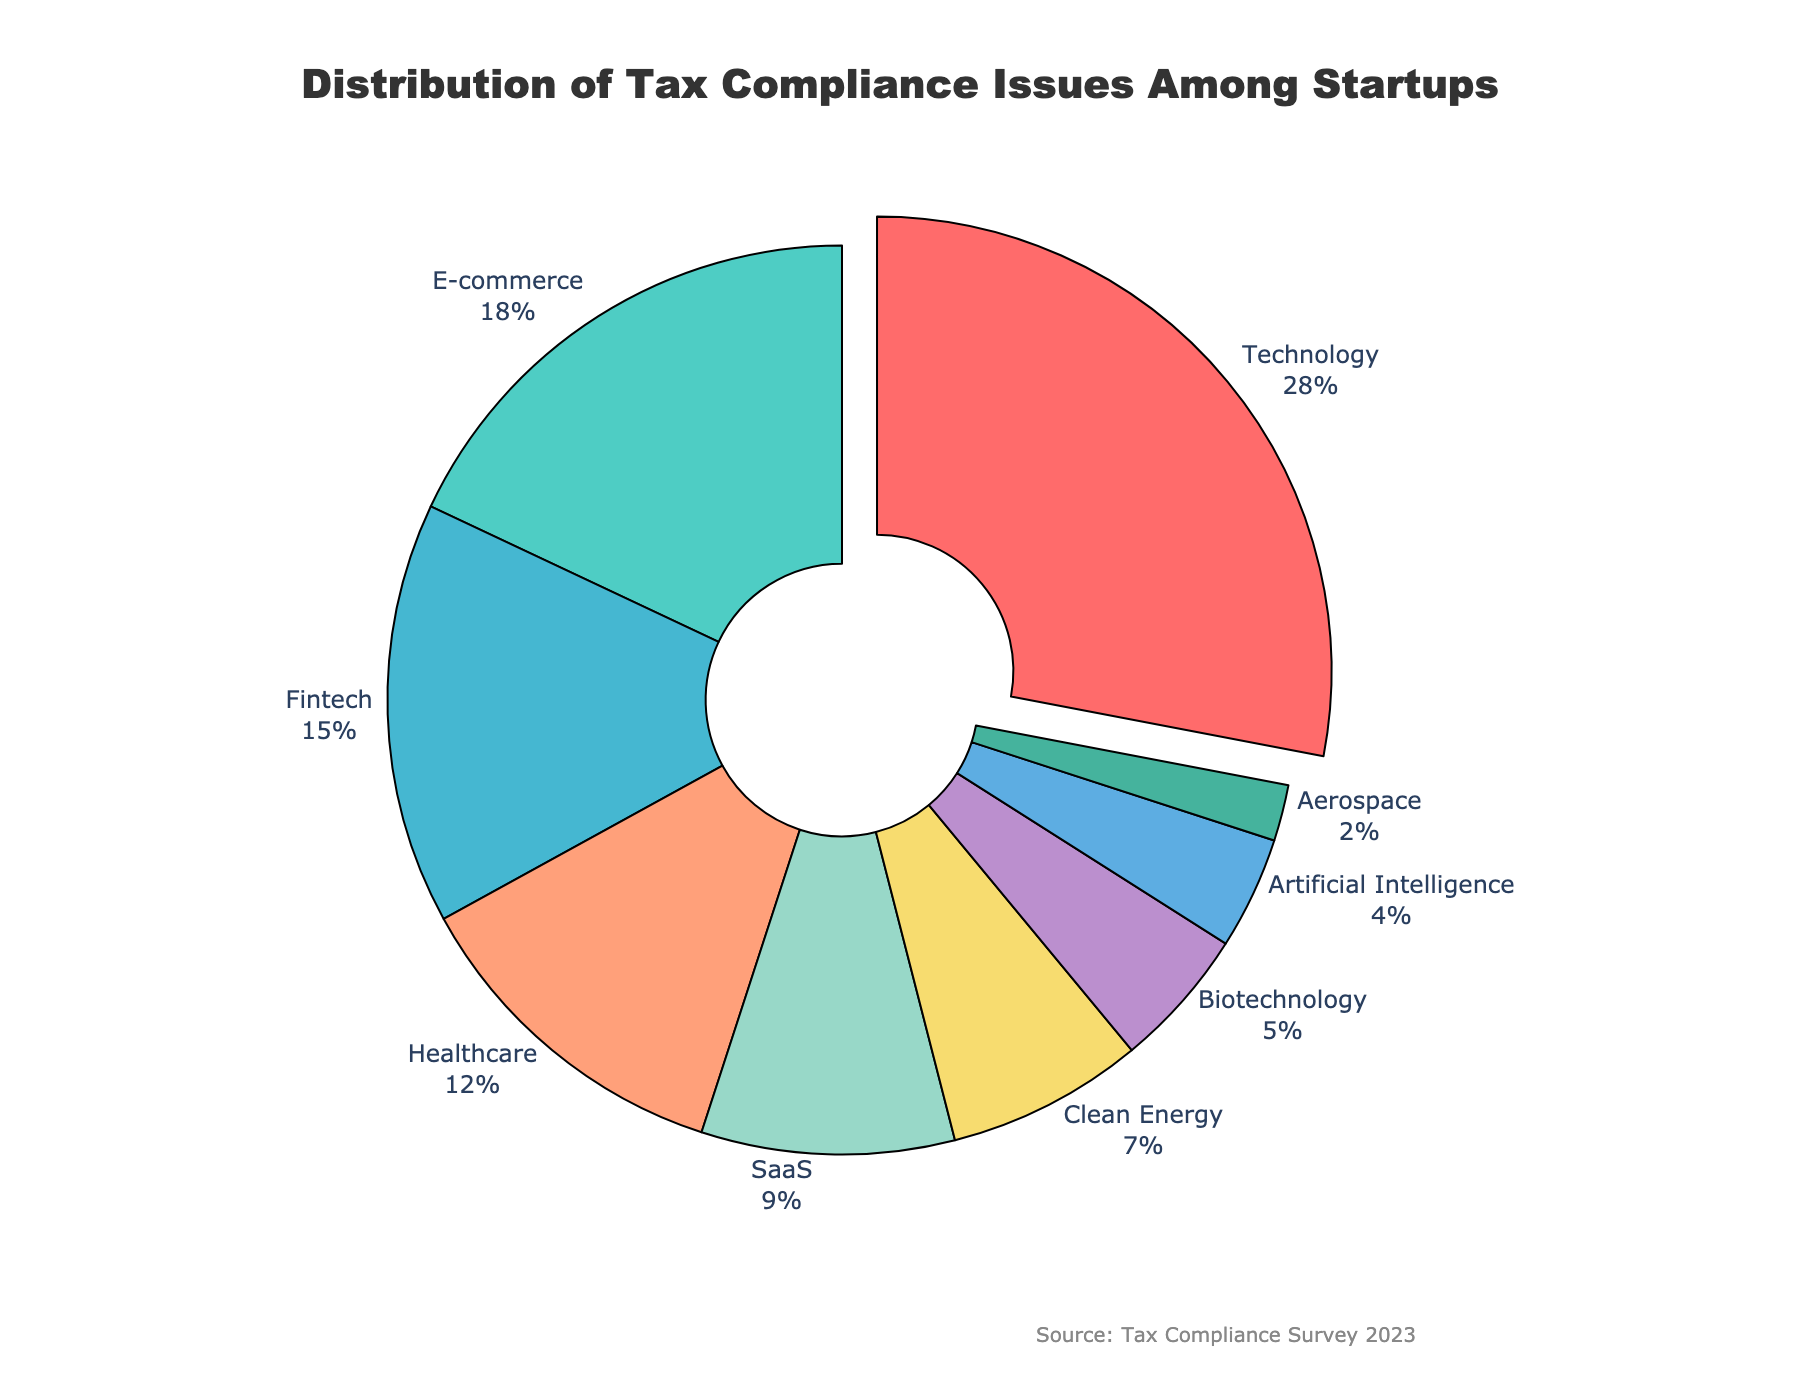What industry sector has the highest proportion of tax compliance issues? First, look at the percentages associated with each industry sector in the pie chart. The 'Technology' sector is highlighted and stands out with the largest proportion at 28%.
Answer: Technology What is the combined percentage of tax compliance issues for E-commerce and Fintech sectors? Identify the percentages for E-commerce and Fintech sectors from the pie chart (18% and 15% respectively). Add these percentages together: 18% + 15% = 33%.
Answer: 33% Which industry sector has the smallest proportion of tax compliance issues? Identify the sector with the smallest percentage in the pie chart. The 'Aerospace' sector has the lowest proportion at 2%.
Answer: Aerospace How does the percentage of tax compliance issues in the Healthcare sector compare with the Clean Energy sector? Look at the percentages for Healthcare (12%) and Clean Energy (7%) in the pie chart. Calculate their difference: 12% - 7% = 5%. The Healthcare sector has a 5% higher proportion of tax compliance issues than Clean Energy.
Answer: Healthcare has 5% more than Clean Energy What percentage of tax compliance issues do the non-technology sectors combined account for? Sum the percentages of all sectors except Technology: E-commerce (18%), Fintech (15%), Healthcare (12%), SaaS (9%), Clean Energy (7%), Biotechnology (5%), Artificial Intelligence (4%), and Aerospace (2%). Total: 18% + 15% + 12% + 9% + 7% + 5% + 4% + 2% = 72%.
Answer: 72% How many sectors have a higher percentage of tax compliance issues than the 'SaaS' sector? Identify the percentage for 'SaaS' (9%) and count the number of sectors with a higher percentage: Technology (28%), E-commerce (18%), Fintech (15%), Healthcare (12%). There are 4 sectors with a higher percentage than 'SaaS'.
Answer: 4 Which industries combined account for about one-quarter of the tax compliance issues? One-quarter is roughly 25%. Look for a combination of sectors whose total is close to 25%. 'E-commerce' (18%) and 'Biotechnology' (5%) add up to 23%, which is close to 25%.
Answer: E-commerce and Biotechnology What is the total percentage of tax compliance issues in sectors related to technology (Technology, Fintech, AI)? Sum the percentages for 'Technology' (28%), 'Fintech' (15%), and 'Artificial Intelligence' (4%): 28% + 15% + 4% = 47%.
Answer: 47% How does the total percentage of tax compliance issues in the top three sectors compare to all other sectors combined? Identify the top three sectors ('Technology' 28%, 'E-commerce' 18%, 'Fintech' 15%) and sum their percentages: 28% + 18% + 15% = 61%. Then, sum the percentages of the remaining sectors: Healthcare (12%), SaaS (9%), Clean Energy (7%), Biotechnology (5%), Artificial Intelligence (4%), Aerospace (2%), which totals to 39%. Compare 61% to 39%. The top three sectors account for 61%, which is higher than the combined total of all other sectors.
Answer: The top three sectors have 22% more than all other sectors combined 